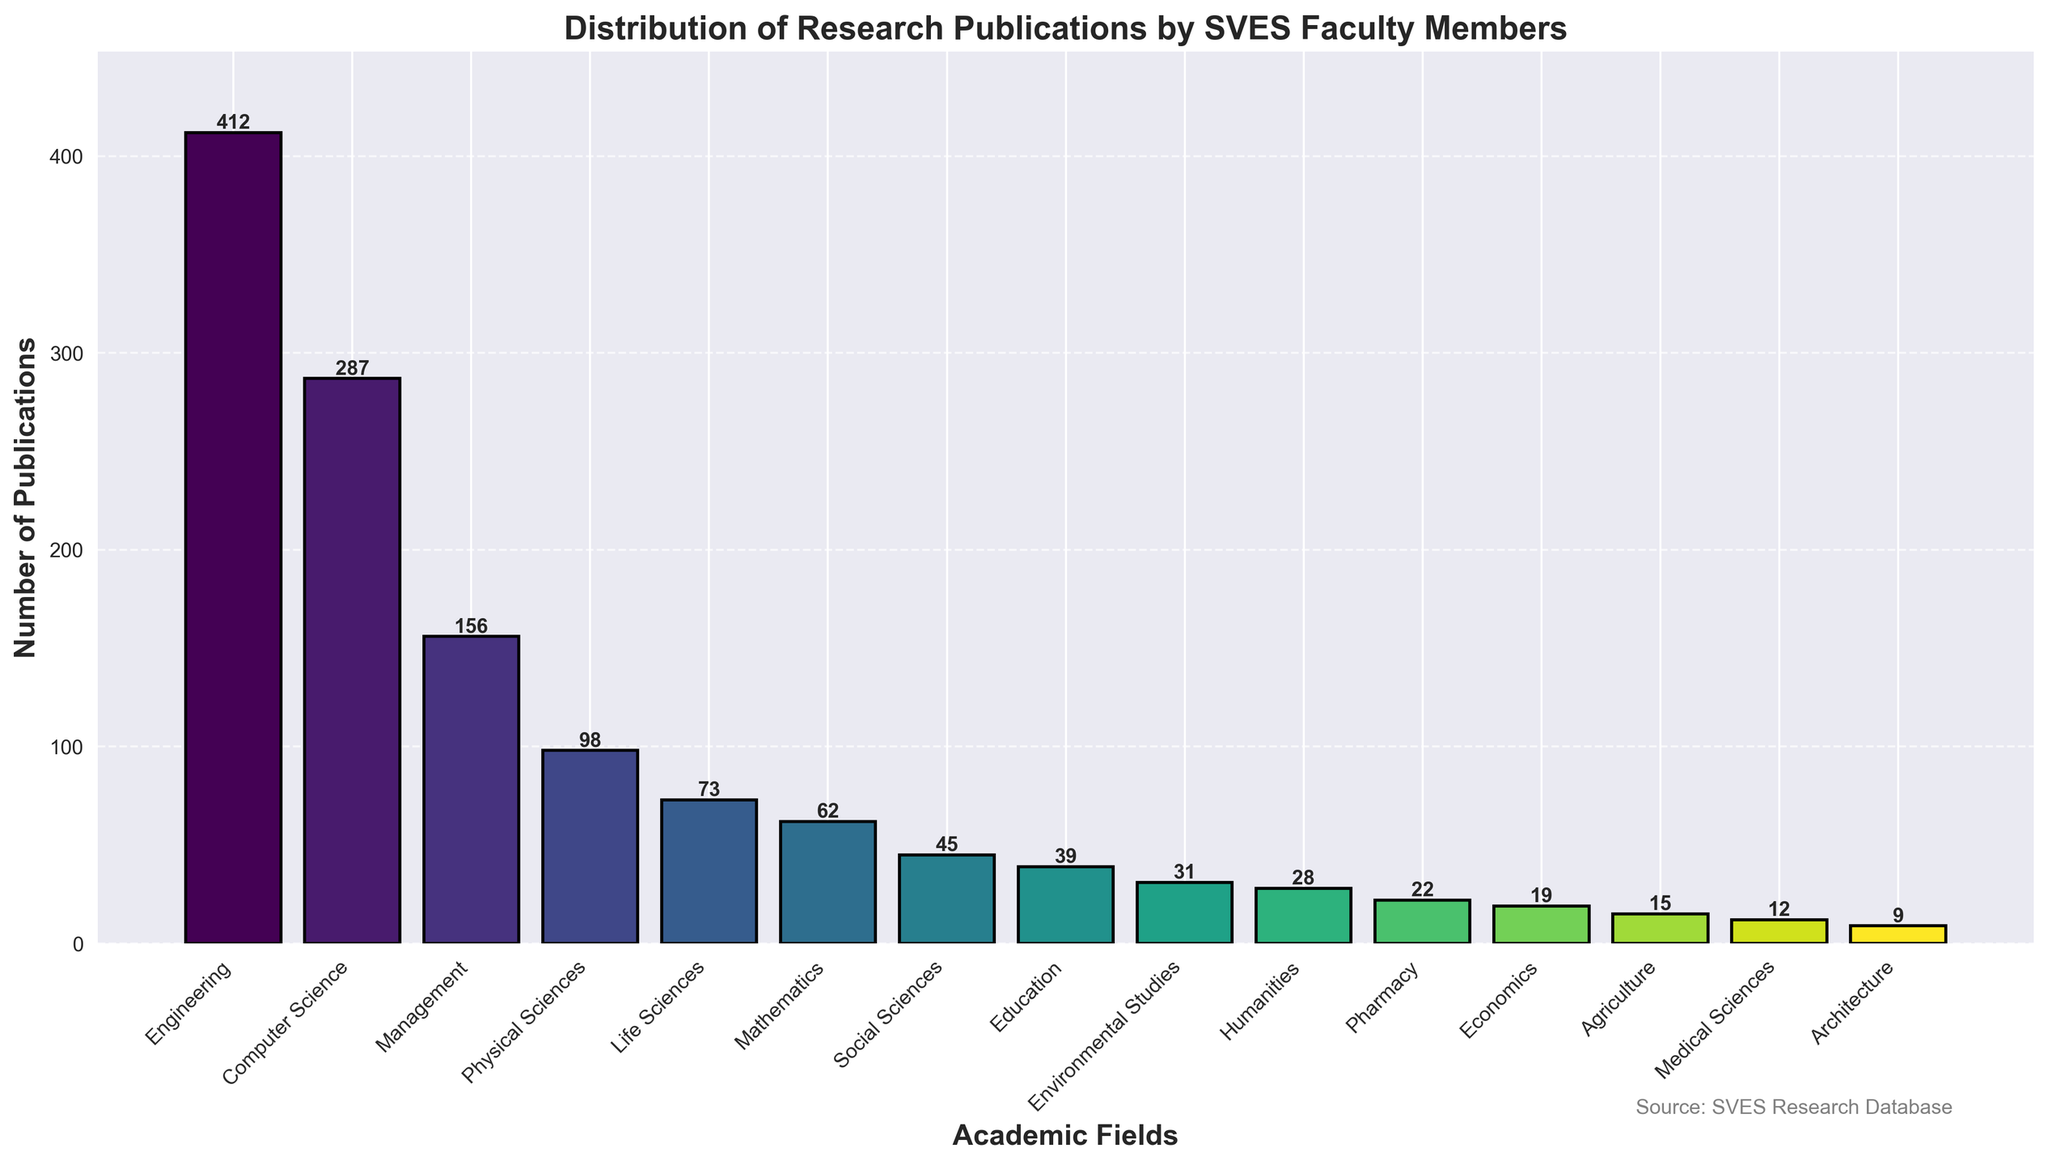Which academic field has the highest number of publications? The tallest bar in the figure represents the field with the highest number of publications. In this case, the bar for 'Engineering' is the tallest, indicating it has the most publications.
Answer: Engineering Which field has the lowest number of publications? The shortest bar in the figure shows the field with the least number of publications. The 'Architecture' bar is the shortest.
Answer: Architecture How many more publications are there in Engineering compared to Computer Science? The height of the bar for 'Engineering' is 412, while for 'Computer Science' it is 287. The difference is calculated as 412 - 287.
Answer: 125 What is the total number of publications across Social Sciences, Education, and Environmental Studies? Sum the heights of the bars for 'Social Sciences', 'Education', and 'Environmental Studies': 45 + 39 + 31.
Answer: 115 Is the number of publications in Management greater than Life Sciences? Compare the heights of the bars for 'Management' and 'Life Sciences'. Management has 156 publications and Life Sciences has 73 publications.
Answer: Yes Which academic fields have more than 100 publications? Identify the fields with bars higher than 100 publications. 'Engineering', 'Computer Science', and 'Management' meet this criterion.
Answer: Engineering, Computer Science, Management What is the average number of publications for Medical Sciences, Education, and Humanities? Sum the number of publications for 'Medical Sciences' (12), 'Education' (39), and 'Humanities' (28), and divide by the number of fields (3): (12 + 39 + 28) / 3.
Answer: 26.33 What is the median number of publications for all the academic fields listed? List the number of publications in ascending order and find the middle value. Ordered values: 9, 12, 15, 19, 22, 28, 31, 39, 45, 62, 73, 98, 156, 287, 412. The middle value is the 8th value: 39.
Answer: 39 What's the difference in the number of publications between Economics and Pharmacy? Subtract the number of publications for 'Economics' (19) from 'Pharmacy' (22): 22 - 19.
Answer: 3 